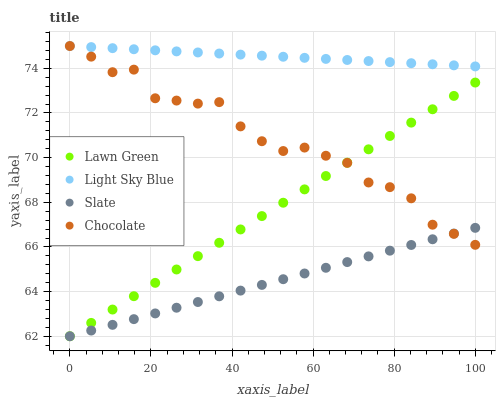Does Slate have the minimum area under the curve?
Answer yes or no. Yes. Does Light Sky Blue have the maximum area under the curve?
Answer yes or no. Yes. Does Light Sky Blue have the minimum area under the curve?
Answer yes or no. No. Does Slate have the maximum area under the curve?
Answer yes or no. No. Is Lawn Green the smoothest?
Answer yes or no. Yes. Is Chocolate the roughest?
Answer yes or no. Yes. Is Slate the smoothest?
Answer yes or no. No. Is Slate the roughest?
Answer yes or no. No. Does Lawn Green have the lowest value?
Answer yes or no. Yes. Does Light Sky Blue have the lowest value?
Answer yes or no. No. Does Chocolate have the highest value?
Answer yes or no. Yes. Does Slate have the highest value?
Answer yes or no. No. Is Slate less than Light Sky Blue?
Answer yes or no. Yes. Is Light Sky Blue greater than Lawn Green?
Answer yes or no. Yes. Does Chocolate intersect Slate?
Answer yes or no. Yes. Is Chocolate less than Slate?
Answer yes or no. No. Is Chocolate greater than Slate?
Answer yes or no. No. Does Slate intersect Light Sky Blue?
Answer yes or no. No. 